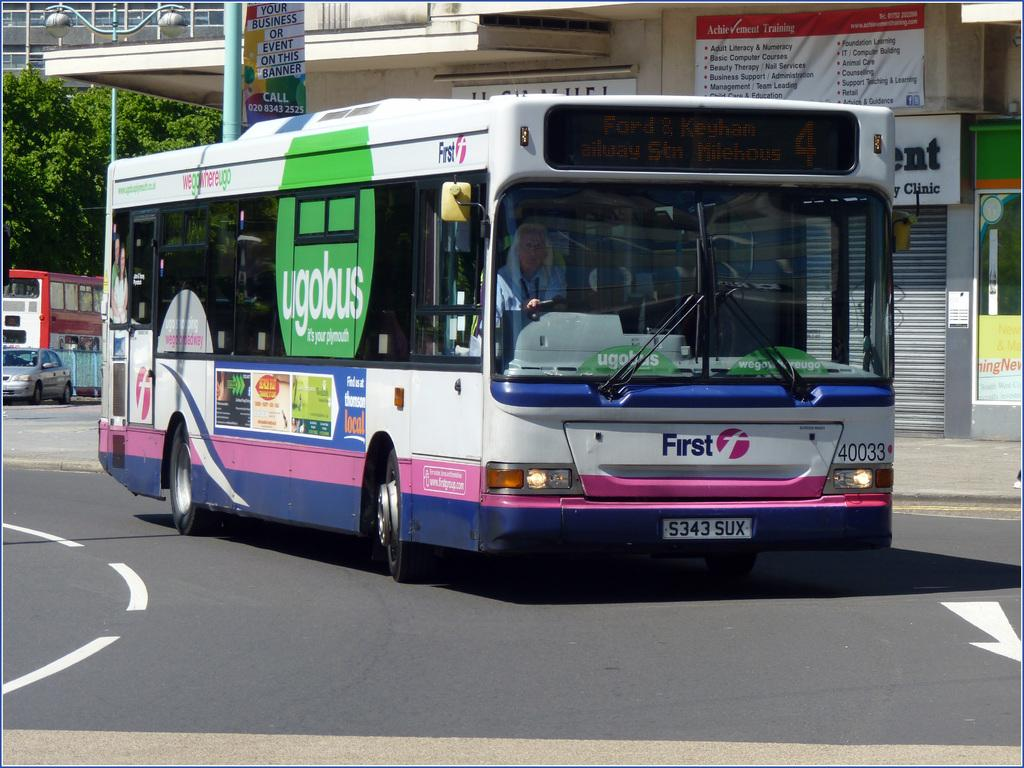<image>
Share a concise interpretation of the image provided. A Ugobus rounds the corner in front of a building. 